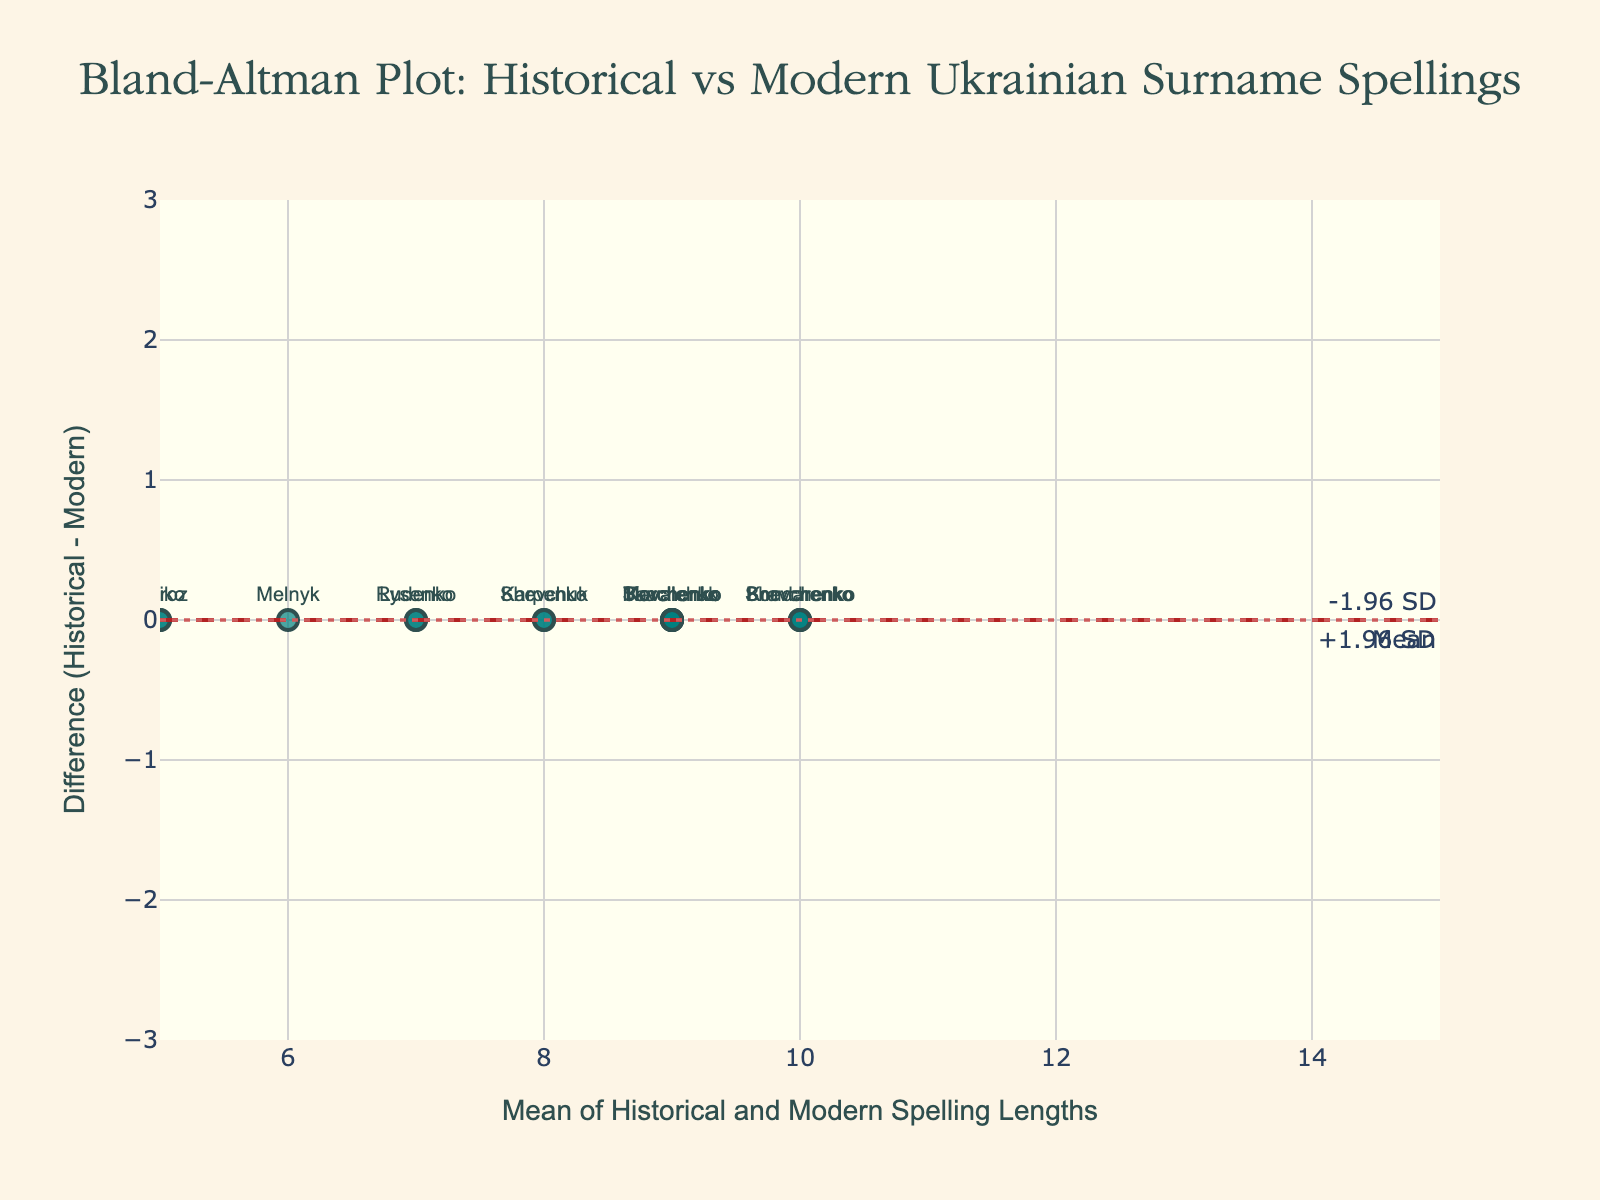What's the title of the plot? The title is located at the top of the plot and usually describes the overall purpose of the figure.
Answer: Bland-Altman Plot: Historical vs Modern Ukrainian Surname Spellings How many data points are there in the plot? Each data point represents a surname, and you can count the markers with their associated texts (surnames) on the plot.
Answer: 15 What is the range of the x-axis? The range of the x-axis can be determined by looking at the scale or the limit of the axis.
Answer: 5 to 15 Which surnames have the largest differences between historical and modern spellings? Look for the points that are furthest from the zero line on the y-axis. The text labels next to these points indicate the surnames.
Answer: Shevchenko, Shevchuk, Kovalchuk What are the upper and lower limits of agreement on this plot? The limits of agreement are indicated by the dotted lines on the plot, with their y-coordinates labeled as +1.96 SD and -1.96 SD.
Answer: +1.96 SD and -1.96 SD What is the mean difference between historical and modern spellings? The mean difference can be observed as the dashed line labeled 'Mean' on the plot.
Answer: Mean What are the mean spelling lengths for Kovalenko and Moroz, respectively? To find the means, locate the x-values for these surnames on the plot.
Answer: Kovalenko: 8, Moroz: 5.5 Which surname has the shortest total spelling length (based on historical and modern)? Determine the surname with the smallest x-value (mean of historical and modern spelling lengths).
Answer: Moroz Which data point has a zero difference between historical and modern spellings? Look for the point at y=0 on the plot and read the associated surname text.
Answer: Moroz Are there any surnames that have the same difference value? If so, which are they? Identify points that have the same y-coordinate and check their labels.
Answer: Kovalenko, Bondarenko, Tkachenko, Kravchenko, Savchenko, Melnyk, Boiko, Karpenko, Lysenko, Marchenko, Rudenko 